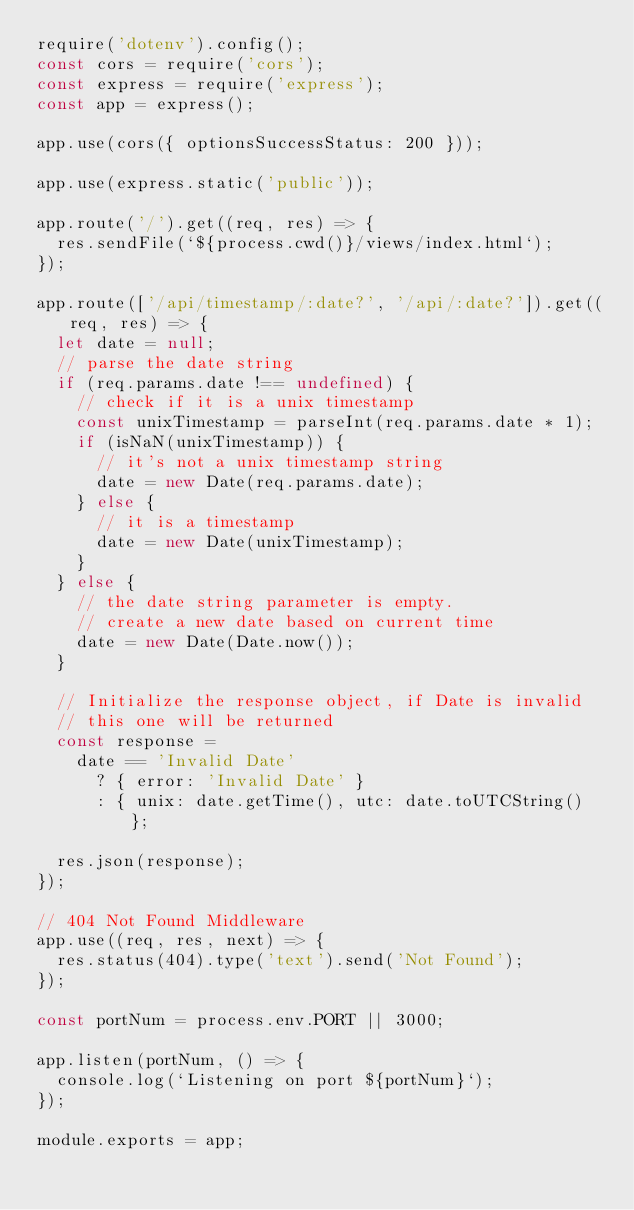Convert code to text. <code><loc_0><loc_0><loc_500><loc_500><_JavaScript_>require('dotenv').config();
const cors = require('cors');
const express = require('express');
const app = express();

app.use(cors({ optionsSuccessStatus: 200 }));

app.use(express.static('public'));

app.route('/').get((req, res) => {
  res.sendFile(`${process.cwd()}/views/index.html`);
});

app.route(['/api/timestamp/:date?', '/api/:date?']).get((req, res) => {
  let date = null;
  // parse the date string
  if (req.params.date !== undefined) {
    // check if it is a unix timestamp
    const unixTimestamp = parseInt(req.params.date * 1);
    if (isNaN(unixTimestamp)) {
      // it's not a unix timestamp string
      date = new Date(req.params.date);
    } else {
      // it is a timestamp
      date = new Date(unixTimestamp);
    }
  } else {
    // the date string parameter is empty.
    // create a new date based on current time
    date = new Date(Date.now());
  }

  // Initialize the response object, if Date is invalid
  // this one will be returned
  const response =
    date == 'Invalid Date'
      ? { error: 'Invalid Date' }
      : { unix: date.getTime(), utc: date.toUTCString() };

  res.json(response);
});

// 404 Not Found Middleware
app.use((req, res, next) => {
  res.status(404).type('text').send('Not Found');
});

const portNum = process.env.PORT || 3000;

app.listen(portNum, () => {
  console.log(`Listening on port ${portNum}`);
});

module.exports = app;</code> 